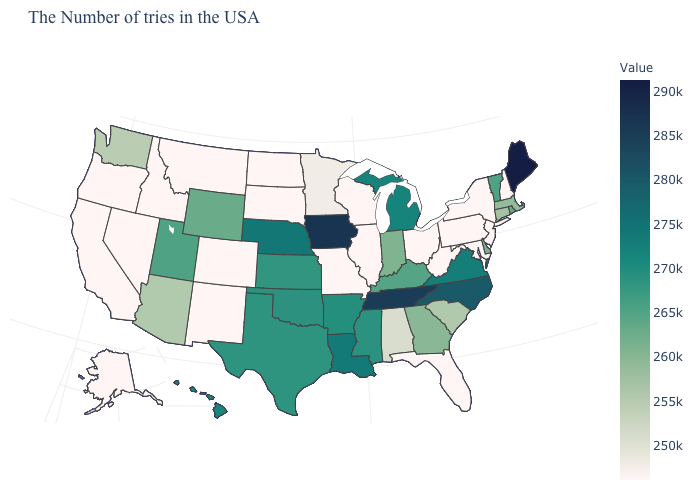Does Maryland have the lowest value in the USA?
Keep it brief. Yes. Is the legend a continuous bar?
Quick response, please. Yes. Among the states that border New Hampshire , which have the lowest value?
Be succinct. Massachusetts. Which states have the lowest value in the USA?
Be succinct. New Hampshire, New York, New Jersey, Maryland, Pennsylvania, West Virginia, Ohio, Florida, Wisconsin, Illinois, Missouri, South Dakota, North Dakota, Colorado, New Mexico, Montana, Idaho, Nevada, California, Oregon, Alaska. Is the legend a continuous bar?
Write a very short answer. Yes. Among the states that border Pennsylvania , does Maryland have the lowest value?
Write a very short answer. Yes. Does Minnesota have the highest value in the MidWest?
Answer briefly. No. 